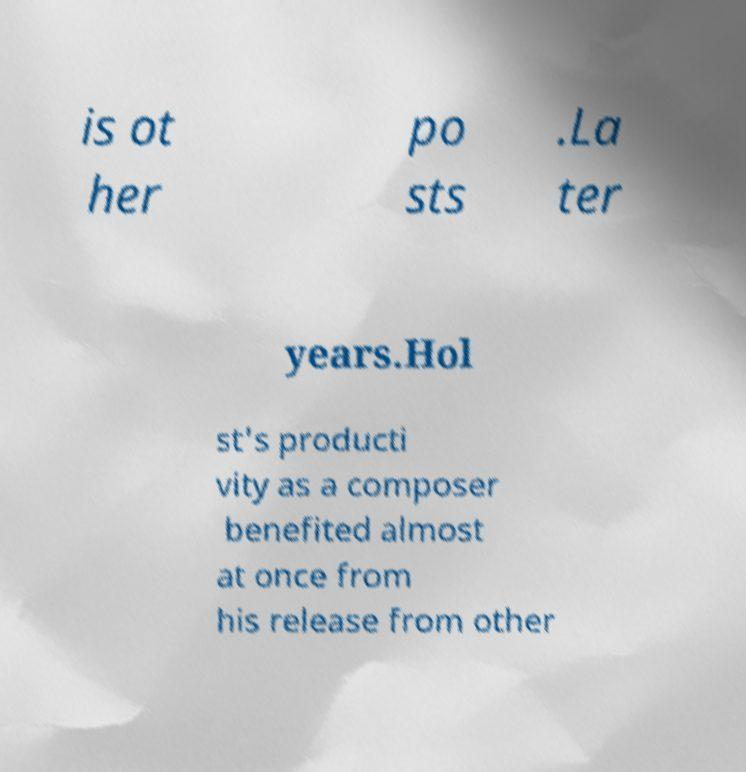Could you extract and type out the text from this image? is ot her po sts .La ter years.Hol st's producti vity as a composer benefited almost at once from his release from other 